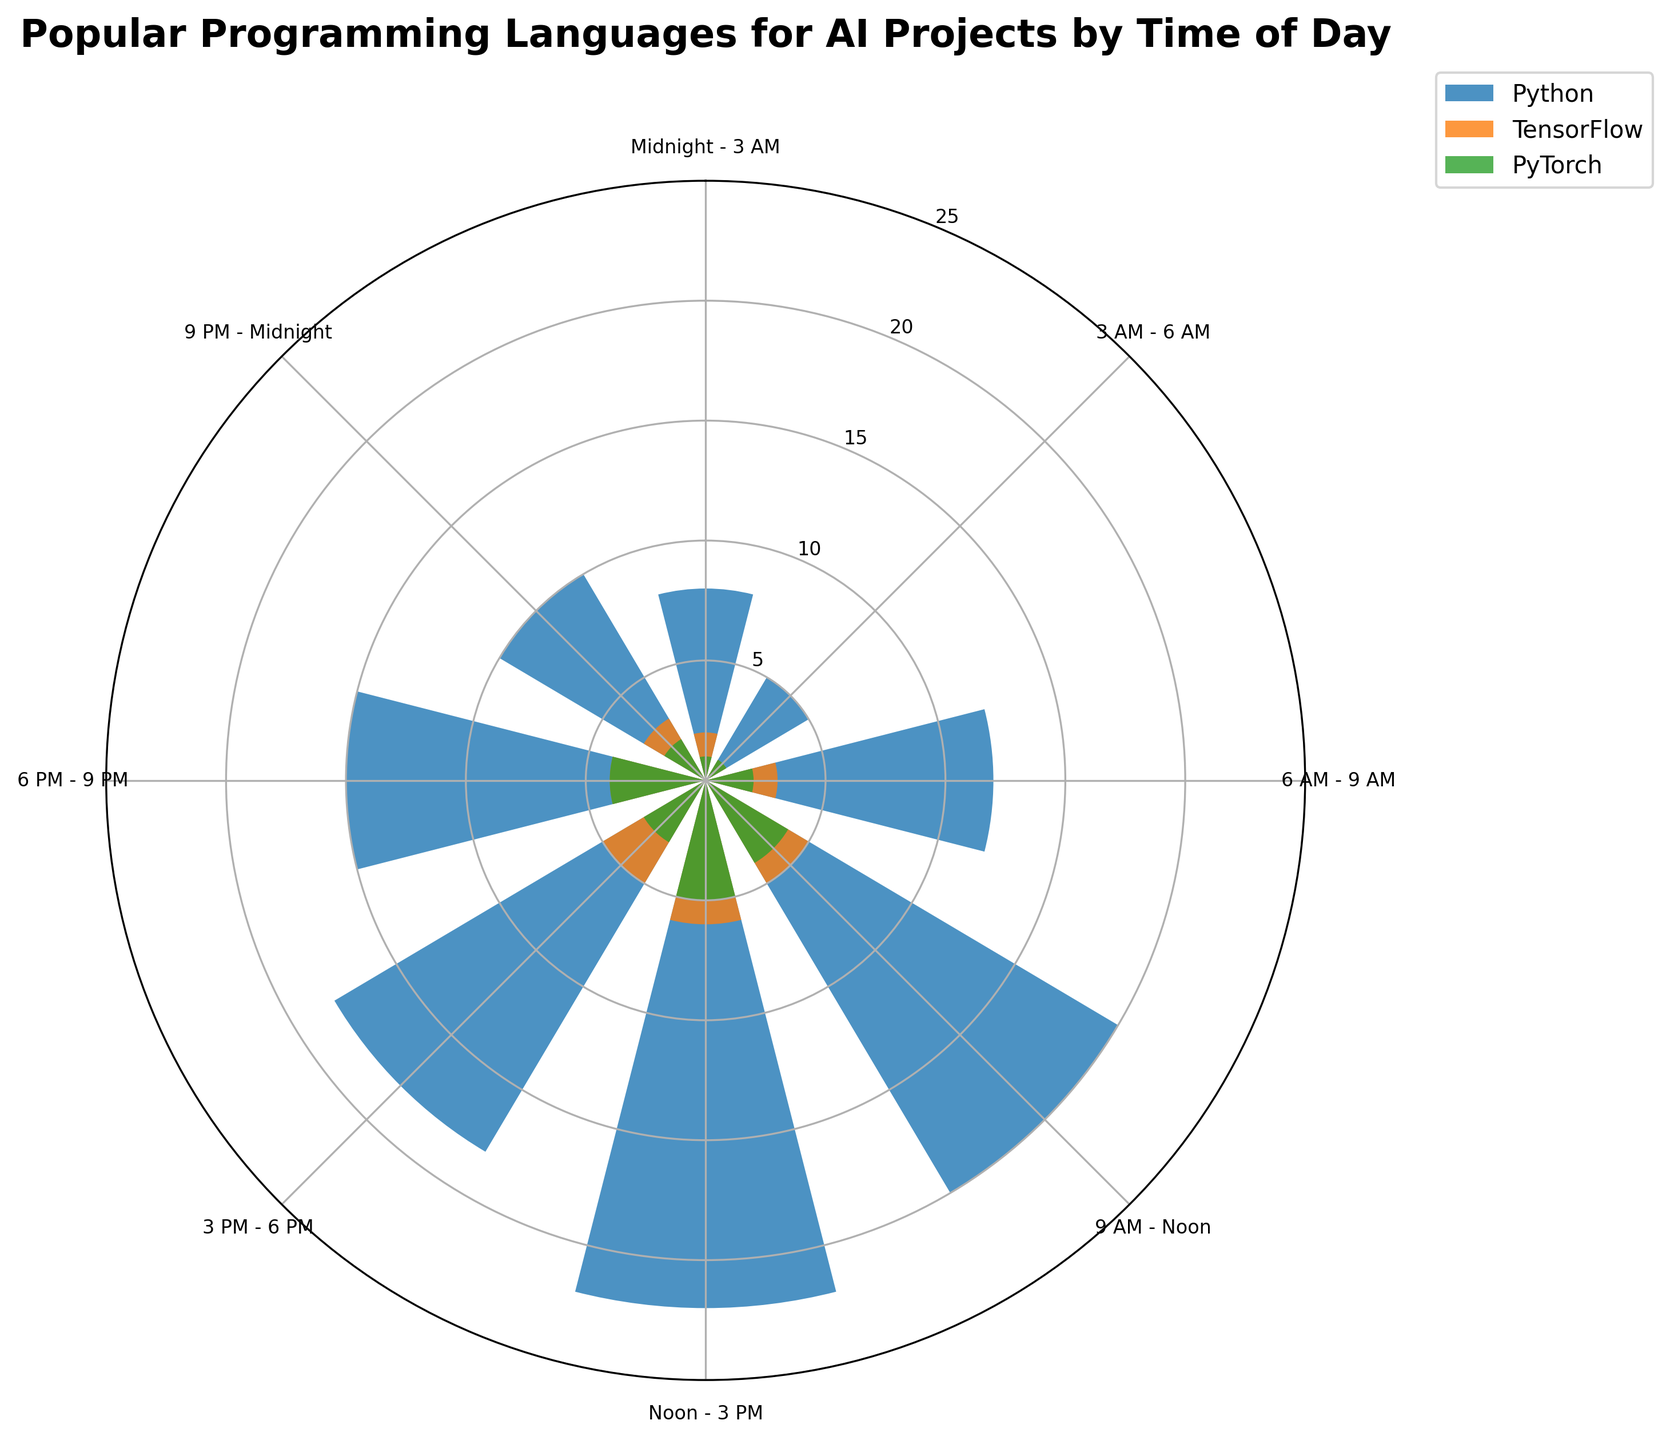what is the title of the plot? The title of the plot is usually placed at the top of the figure and describes the overall content. Here, it reads 'Popular Programming Languages for AI Projects by Time of Day'.
Answer: 'Popular Programming Languages for AI Projects by Time of Day' how many programming languages are depicted in the plot? The plot labels each bar group with the name of the programming languages. By viewing the legend or the labels directly on the plot, we can count how many different names are present.
Answer: 3 which programming language has the highest usage in the Noon - 3 PM time slot? By examining the Noon - 3 PM segment, we find that the bar representing Python reaches the highest point.
Answer: Python In which time slot is TensorFlow used the least? Look through all segments to find the one where the height of the TensorFlow bar is the smallest. It is the 3 AM - 6 AM slot.
Answer: 3 AM - 6 AM how does the usage of PyTorch change between 9 AM - Noon and noon - 3 PM? To solve this, examine the heights of PyTorch bars at the two time slots. PyTorch usage increases from 4 to 5.
Answer: increases compare Python usage at 9 AM - Noon and at 3 PM - 6 PM By comparing the heights of Python bars at these time slots, we see Python usage goes from 20 at 9 AM - Noon to 18 at 3 PM - 6 PM.
Answer: It decreases What is the average usage of TensorFlow across all time slots? Summing up TensorFlow's usage values (2+1+3+5+6+5+4+3) gives 29. There are 8 time slots, so average usage is 29/8 = 3.625.
Answer: 3.625 which time slot has the most balanced use of all three programming languages? A balanced use means the heights of the bars are relatively similar. By comparing all time slots, 6 PM - 9 PM seems the most balanced with values 15, 4, and 4.
Answer: 6 PM - 9 PM which programming language shows the most variation in usage over different time slots? Comparing the heights of the bars for each language, Python shows the most variation, varying from 5 to 22.
Answer: Python 